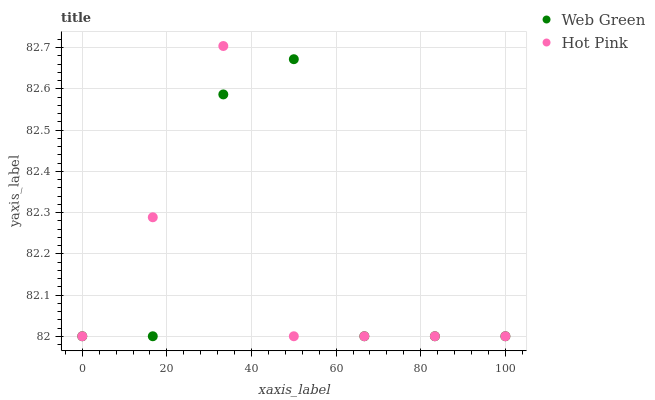Does Hot Pink have the minimum area under the curve?
Answer yes or no. Yes. Does Web Green have the maximum area under the curve?
Answer yes or no. Yes. Does Web Green have the minimum area under the curve?
Answer yes or no. No. Is Hot Pink the smoothest?
Answer yes or no. Yes. Is Web Green the roughest?
Answer yes or no. Yes. Is Web Green the smoothest?
Answer yes or no. No. Does Hot Pink have the lowest value?
Answer yes or no. Yes. Does Hot Pink have the highest value?
Answer yes or no. Yes. Does Web Green have the highest value?
Answer yes or no. No. Does Hot Pink intersect Web Green?
Answer yes or no. Yes. Is Hot Pink less than Web Green?
Answer yes or no. No. Is Hot Pink greater than Web Green?
Answer yes or no. No. 